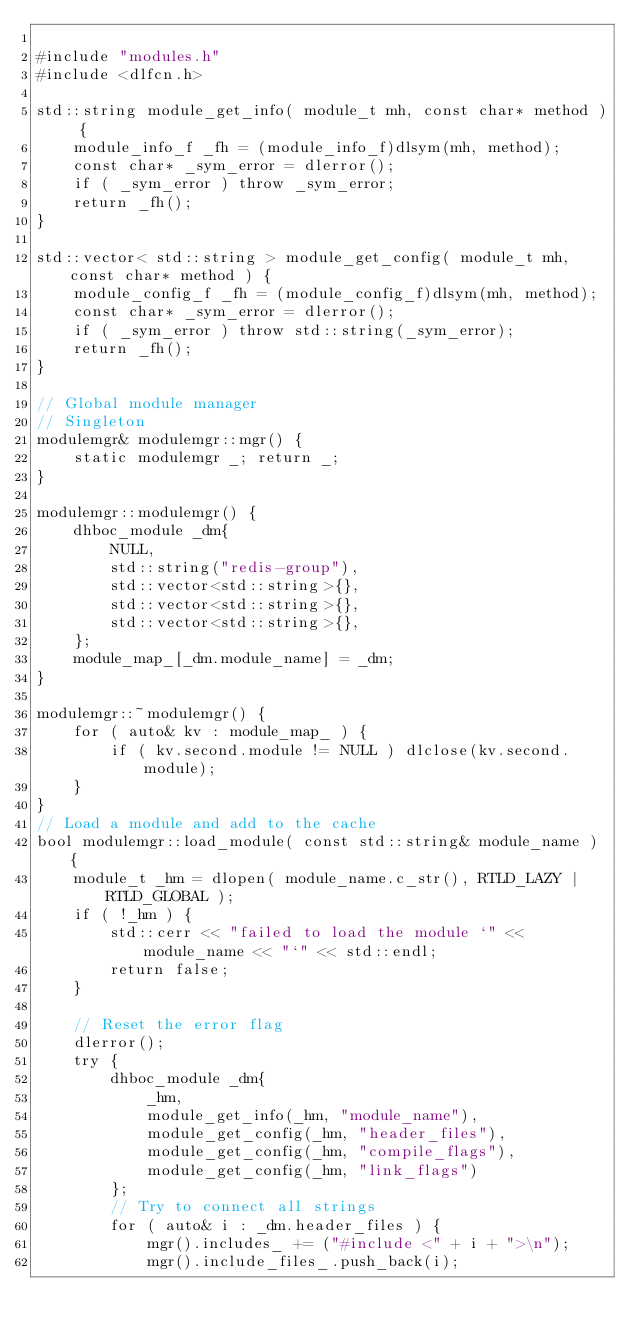Convert code to text. <code><loc_0><loc_0><loc_500><loc_500><_C++_>
#include "modules.h"
#include <dlfcn.h>

std::string module_get_info( module_t mh, const char* method ) {
    module_info_f _fh = (module_info_f)dlsym(mh, method);
    const char* _sym_error = dlerror();
    if ( _sym_error ) throw _sym_error;
    return _fh();
}

std::vector< std::string > module_get_config( module_t mh, const char* method ) {
    module_config_f _fh = (module_config_f)dlsym(mh, method);
    const char* _sym_error = dlerror();
    if ( _sym_error ) throw std::string(_sym_error);
    return _fh();
}

// Global module manager
// Singleton
modulemgr& modulemgr::mgr() {
    static modulemgr _; return _;
}

modulemgr::modulemgr() {
    dhboc_module _dm{
        NULL,
        std::string("redis-group"),
        std::vector<std::string>{},
        std::vector<std::string>{},
        std::vector<std::string>{},
    };
    module_map_[_dm.module_name] = _dm;
}

modulemgr::~modulemgr() {
    for ( auto& kv : module_map_ ) {
        if ( kv.second.module != NULL ) dlclose(kv.second.module);
    }
}
// Load a module and add to the cache
bool modulemgr::load_module( const std::string& module_name ) {
    module_t _hm = dlopen( module_name.c_str(), RTLD_LAZY | RTLD_GLOBAL );
    if ( !_hm ) {
        std::cerr << "failed to load the module `" << module_name << "`" << std::endl;
        return false;
    }

    // Reset the error flag
    dlerror();
    try {
        dhboc_module _dm{
            _hm, 
            module_get_info(_hm, "module_name"),
            module_get_config(_hm, "header_files"),
            module_get_config(_hm, "compile_flags"),
            module_get_config(_hm, "link_flags")
        };
        // Try to connect all strings
        for ( auto& i : _dm.header_files ) {
            mgr().includes_ += ("#include <" + i + ">\n");
            mgr().include_files_.push_back(i);</code> 